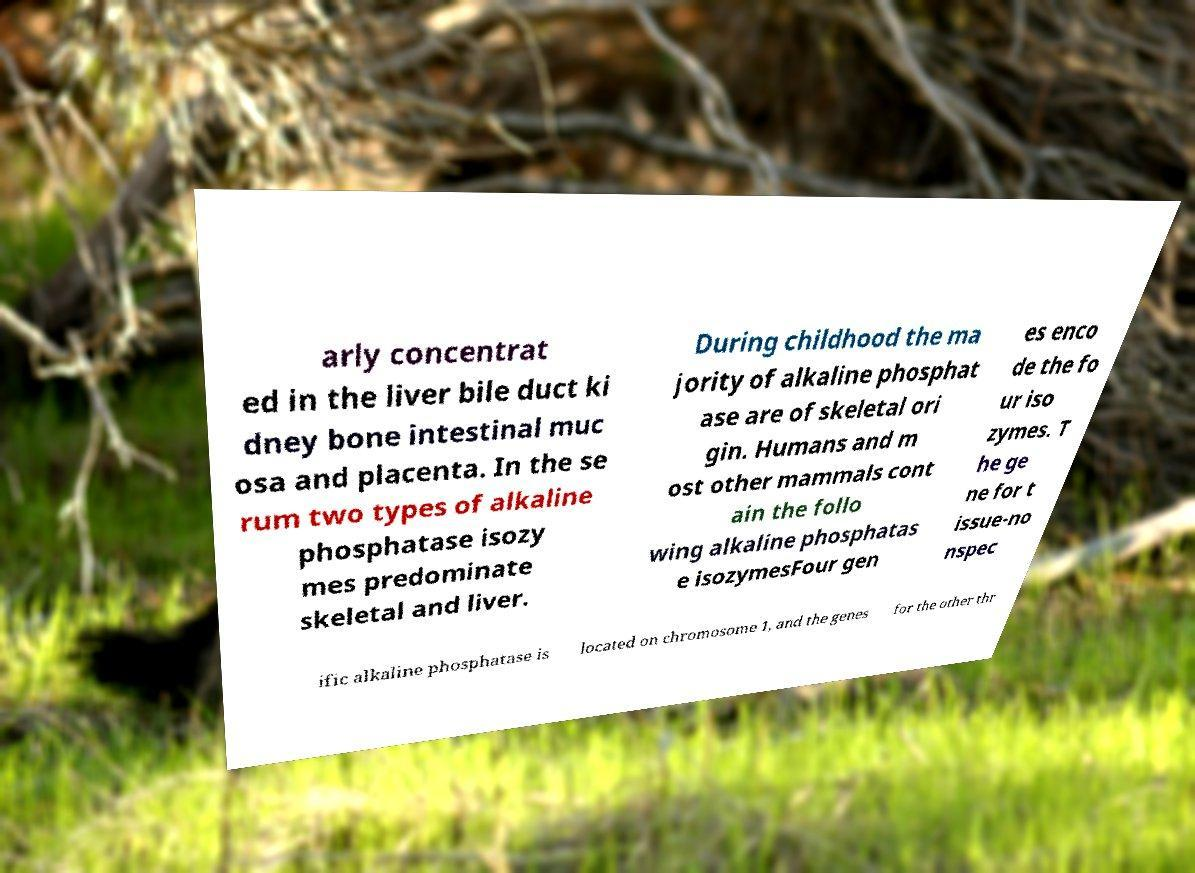What messages or text are displayed in this image? I need them in a readable, typed format. arly concentrat ed in the liver bile duct ki dney bone intestinal muc osa and placenta. In the se rum two types of alkaline phosphatase isozy mes predominate skeletal and liver. During childhood the ma jority of alkaline phosphat ase are of skeletal ori gin. Humans and m ost other mammals cont ain the follo wing alkaline phosphatas e isozymesFour gen es enco de the fo ur iso zymes. T he ge ne for t issue-no nspec ific alkaline phosphatase is located on chromosome 1, and the genes for the other thr 